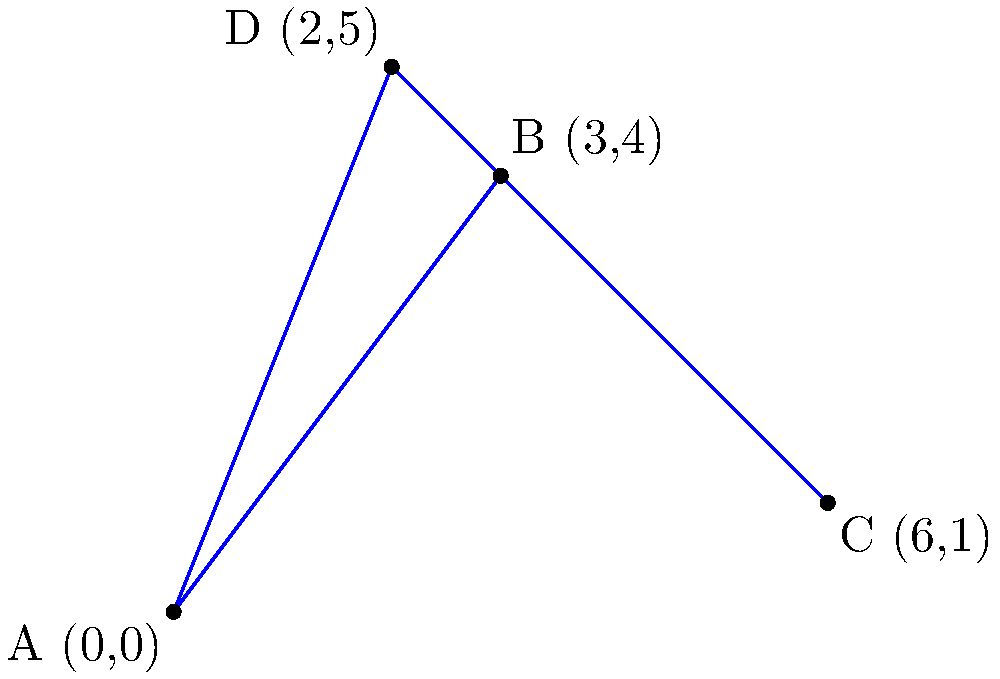A cleanup team needs to visit four polluted sites represented by points A(0,0), B(3,4), C(6,1), and D(2,5) on a coordinate plane. What is the shortest possible path that covers all four sites, assuming the team starts and ends at point A? Give your answer as the total distance traveled rounded to two decimal places. To find the shortest path, we need to calculate the distances between all points and determine the optimal route. Let's follow these steps:

1) Calculate the distances between all pairs of points using the distance formula:
   $d = \sqrt{(x_2-x_1)^2 + (y_2-y_1)^2}$

   AB = $\sqrt{(3-0)^2 + (4-0)^2} = 5$
   AC = $\sqrt{(6-0)^2 + (1-0)^2} = \sqrt{37} \approx 6.08$
   AD = $\sqrt{(2-0)^2 + (5-0)^2} = \sqrt{29} \approx 5.39$
   BC = $\sqrt{(6-3)^2 + (1-4)^2} = \sqrt{18} \approx 4.24$
   BD = $\sqrt{(2-3)^2 + (5-4)^2} = \sqrt{2} \approx 1.41$
   CD = $\sqrt{(2-6)^2 + (5-1)^2} = \sqrt{32} \approx 5.66$

2) The possible routes starting and ending at A are:
   A-B-C-D-A
   A-B-D-C-A
   A-C-B-D-A
   A-C-D-B-A
   A-D-B-C-A
   A-D-C-B-A

3) Calculate the total distance for each route:
   A-B-C-D-A: 5 + 4.24 + 5.66 + 5.39 = 20.29
   A-B-D-C-A: 5 + 1.41 + 5.66 + 6.08 = 18.15
   A-C-B-D-A: 6.08 + 4.24 + 1.41 + 5.39 = 17.12
   A-C-D-B-A: 6.08 + 5.66 + 1.41 + 5 = 18.15
   A-D-B-C-A: 5.39 + 1.41 + 4.24 + 6.08 = 17.12
   A-D-C-B-A: 5.39 + 5.66 + 4.24 + 5 = 20.29

4) The shortest path is either A-C-B-D-A or A-D-B-C-A, both with a total distance of 17.12.

5) Rounding to two decimal places: 17.12
Answer: 17.12 